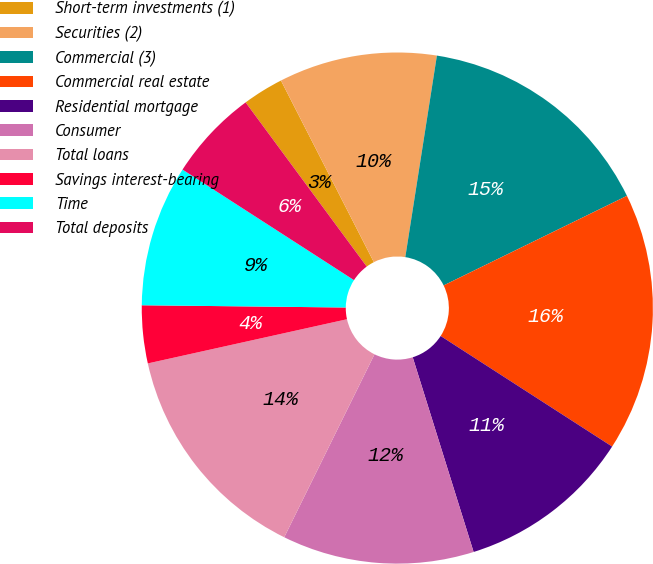Convert chart. <chart><loc_0><loc_0><loc_500><loc_500><pie_chart><fcel>Short-term investments (1)<fcel>Securities (2)<fcel>Commercial (3)<fcel>Commercial real estate<fcel>Residential mortgage<fcel>Consumer<fcel>Total loans<fcel>Savings interest-bearing<fcel>Time<fcel>Total deposits<nl><fcel>2.59%<fcel>10.0%<fcel>15.29%<fcel>16.35%<fcel>11.06%<fcel>12.12%<fcel>14.23%<fcel>3.65%<fcel>8.94%<fcel>5.77%<nl></chart> 